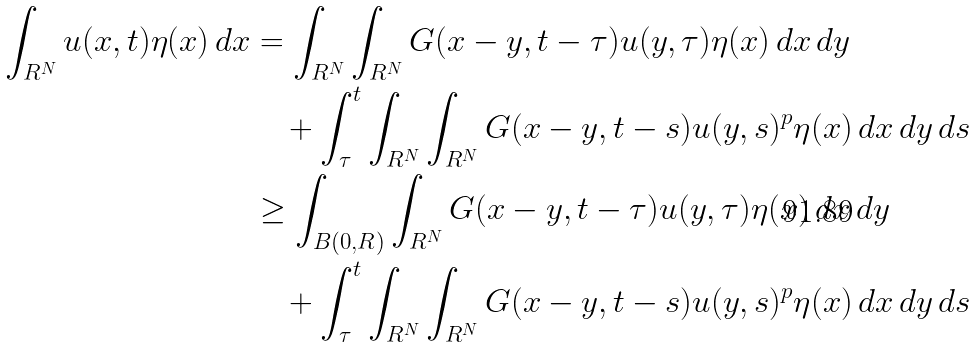Convert formula to latex. <formula><loc_0><loc_0><loc_500><loc_500>\int _ { { R } ^ { N } } u ( x , t ) \eta ( x ) \, d x & = \int _ { { R } ^ { N } } \int _ { { R } ^ { N } } G ( x - y , t - \tau ) u ( y , \tau ) \eta ( x ) \, d x \, d y \\ & \quad + \int _ { \tau } ^ { t } \int _ { { R } ^ { N } } \int _ { { R } ^ { N } } G ( x - y , t - s ) u ( y , s ) ^ { p } \eta ( x ) \, d x \, d y \, d s \\ & \geq \int _ { B ( 0 , R ) } \int _ { { R } ^ { N } } G ( x - y , t - \tau ) u ( y , \tau ) \eta ( x ) \, d x \, d y \\ & \quad + \int _ { \tau } ^ { t } \int _ { { R } ^ { N } } \int _ { { R } ^ { N } } G ( x - y , t - s ) u ( y , s ) ^ { p } \eta ( x ) \, d x \, d y \, d s</formula> 